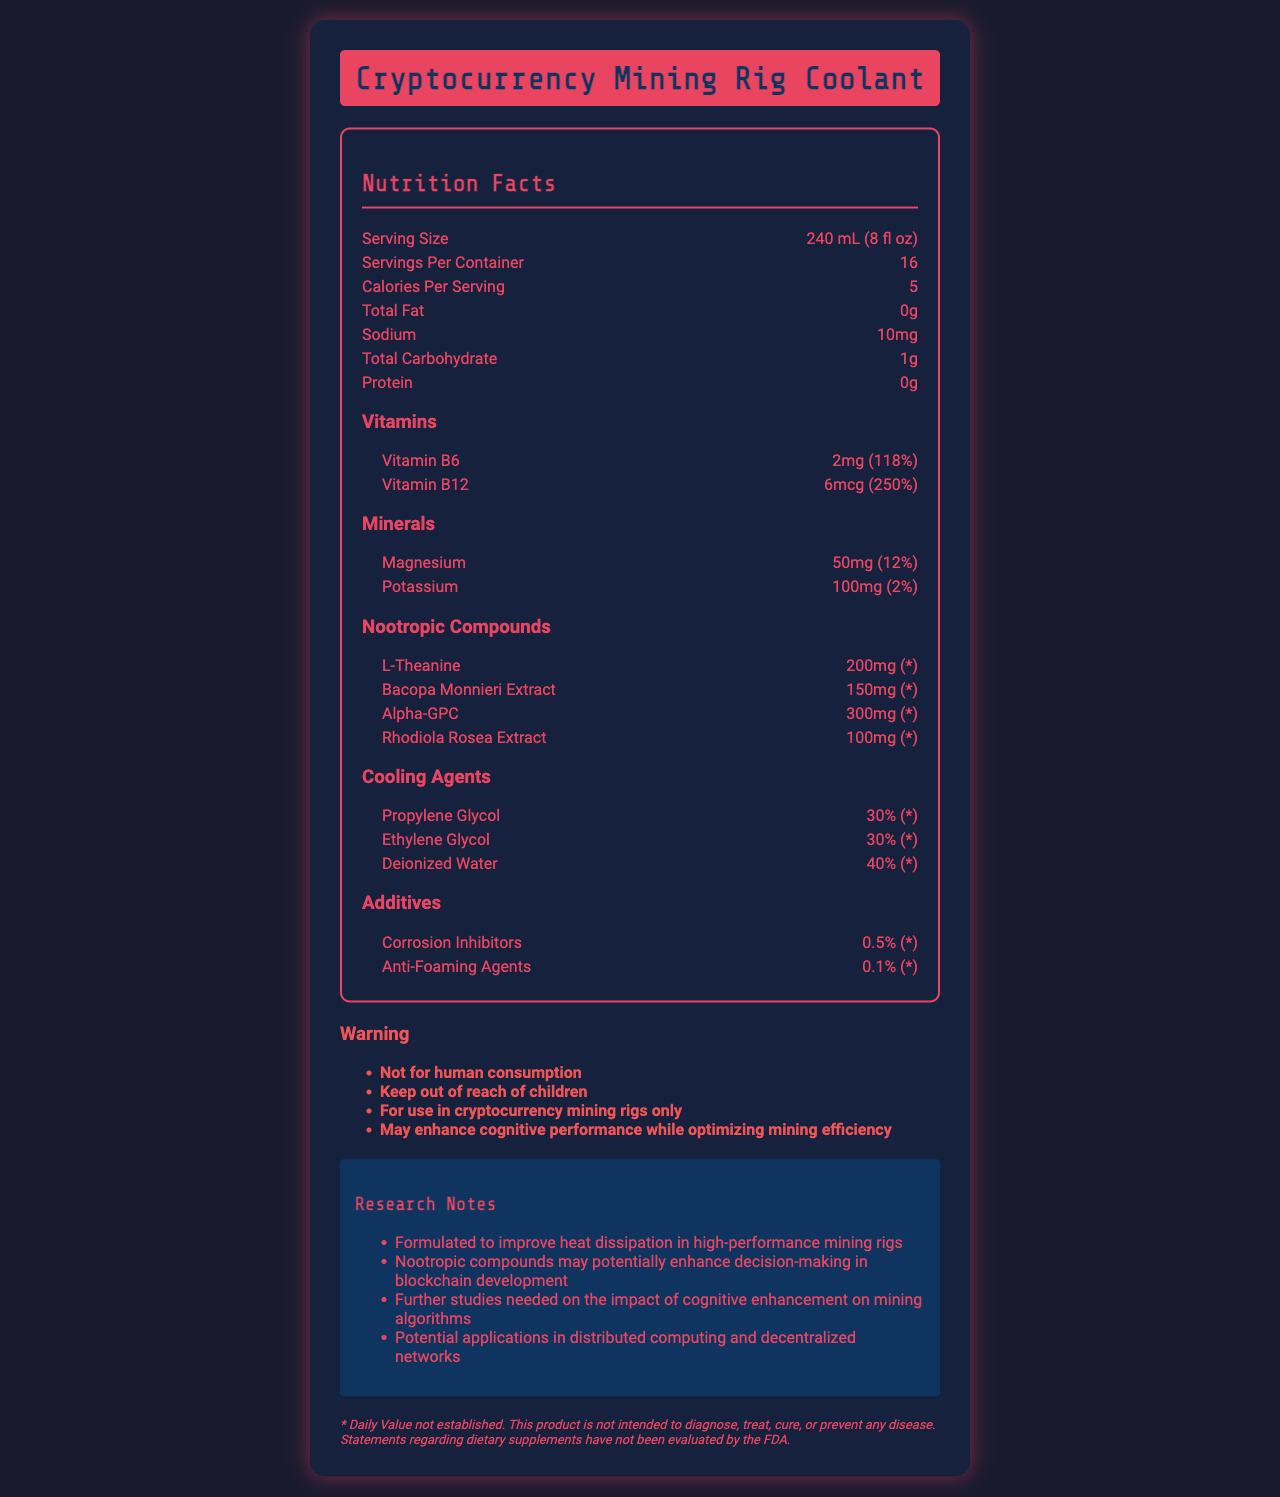what is the serving size for this coolant? The serving size is clearly indicated at the top of the nutrition facts.
Answer: 240 mL (8 fl oz) how many servings are there per container? The number of servings per container is listed right below the serving size in the document.
Answer: 16 what is the amount of L-Theanine per serving? Under the nootropic compounds section, L-Theanine is listed with an amount of 200mg per serving.
Answer: 200mg how much sodium does each serving contain? Sodium content per serving is specified in the nutrition facts section.
Answer: 10mg which mineral is present in the highest amount per serving? Under the minerals section, Potassium is listed with 100mg, which is higher than Magnesium at 50mg.
Answer: Potassium which of the following has the highest daily value percentage? A. Vitamin B6 B. Magnesium C. Potassium D. Vitamin B12 Vitamin B12 has a daily value of 250%, which is higher than Vitamin B6 (118%), Magnesium (12%), and Potassium (2%).
Answer: D. Vitamin B12 which cooling agent is present in the lowest amount? A. Propylene Glycol B. Ethylene Glycol C. Deionized Water D. Corrosion Inhibitors Corrosion Inhibitors are present in 0.5%, which is lower than the percentages of the other listed cooling agents.
Answer: D. Corrosion Inhibitors is this coolant intended for human consumption? The warnings section clearly states "Not for human consumption."
Answer: No does this document provide any insights on the impact of cognitive enhancement on mining algorithms? The research notes mention that further studies are needed on the impact of cognitive enhancement on mining algorithms.
Answer: Yes what are the nootropic compounds included in this coolant? These are listed under the nootropic compounds section in the nutrition facts.
Answer: L-Theanine, Bacopa Monnieri Extract, Alpha-GPC, Rhodiola Rosea Extract what is the main idea of this document? The document provides a detailed breakdown of the composition of the coolant, warnings, and research notes emphasizing its formulation for mining rigs and potential impacts.
Answer: This document outlines the nutrition facts of a cryptocurrency mining rig coolant, which includes added nootropic compounds and cooling agents. It warns against human consumption and details potential research applications. what ongoing studies are mentioned in the research notes? The research notes section specifically mentions ongoing studies about the cognitive enhancement impact on mining algorithms.
Answer: Further studies on the impact of cognitive enhancement on mining algorithms. how much protein is in each serving of this coolant? The nutrition facts section indicates that there is 0g of protein per serving.
Answer: 0g are there any anti-foaming agents in this coolant? The additives section lists anti-foaming agents at 0.1%.
Answer: Yes does this document specify the energy expenditure of the nootropic compounds when used in mining rigs? The document does not provide any information regarding the energy expenditure of nootropic compounds in mining rigs.
Answer: Cannot be determined what daily value percentage is established for L-Theanine? The document indicates that the daily value for L-Theanine is not established, marked with an asterisk.
Answer: * 